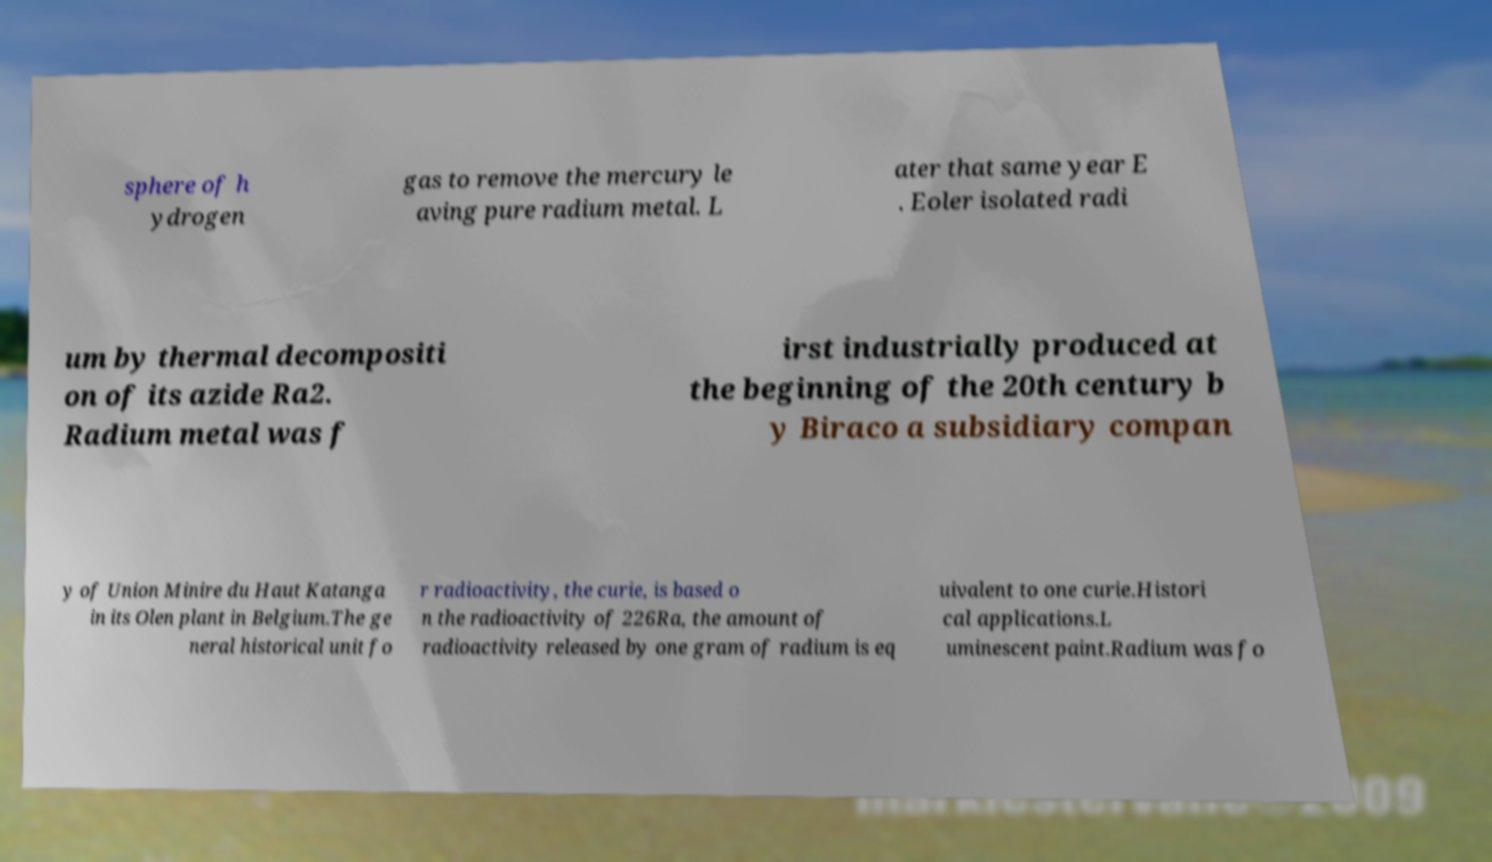For documentation purposes, I need the text within this image transcribed. Could you provide that? sphere of h ydrogen gas to remove the mercury le aving pure radium metal. L ater that same year E . Eoler isolated radi um by thermal decompositi on of its azide Ra2. Radium metal was f irst industrially produced at the beginning of the 20th century b y Biraco a subsidiary compan y of Union Minire du Haut Katanga in its Olen plant in Belgium.The ge neral historical unit fo r radioactivity, the curie, is based o n the radioactivity of 226Ra, the amount of radioactivity released by one gram of radium is eq uivalent to one curie.Histori cal applications.L uminescent paint.Radium was fo 